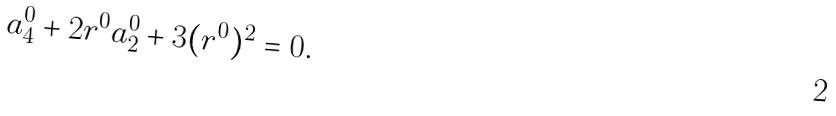Convert formula to latex. <formula><loc_0><loc_0><loc_500><loc_500>a _ { 4 } ^ { 0 } + 2 r ^ { 0 } a _ { 2 } ^ { 0 } + 3 ( r ^ { 0 } ) ^ { 2 } = 0 .</formula> 